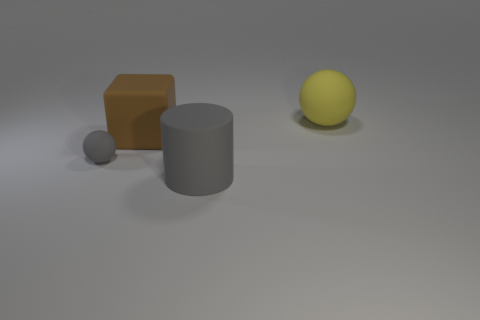Add 4 large brown objects. How many objects exist? 8 Subtract all cylinders. How many objects are left? 3 Subtract 0 brown balls. How many objects are left? 4 Subtract all tiny gray balls. Subtract all cyan matte cylinders. How many objects are left? 3 Add 4 small gray matte things. How many small gray matte things are left? 5 Add 2 large cyan cylinders. How many large cyan cylinders exist? 2 